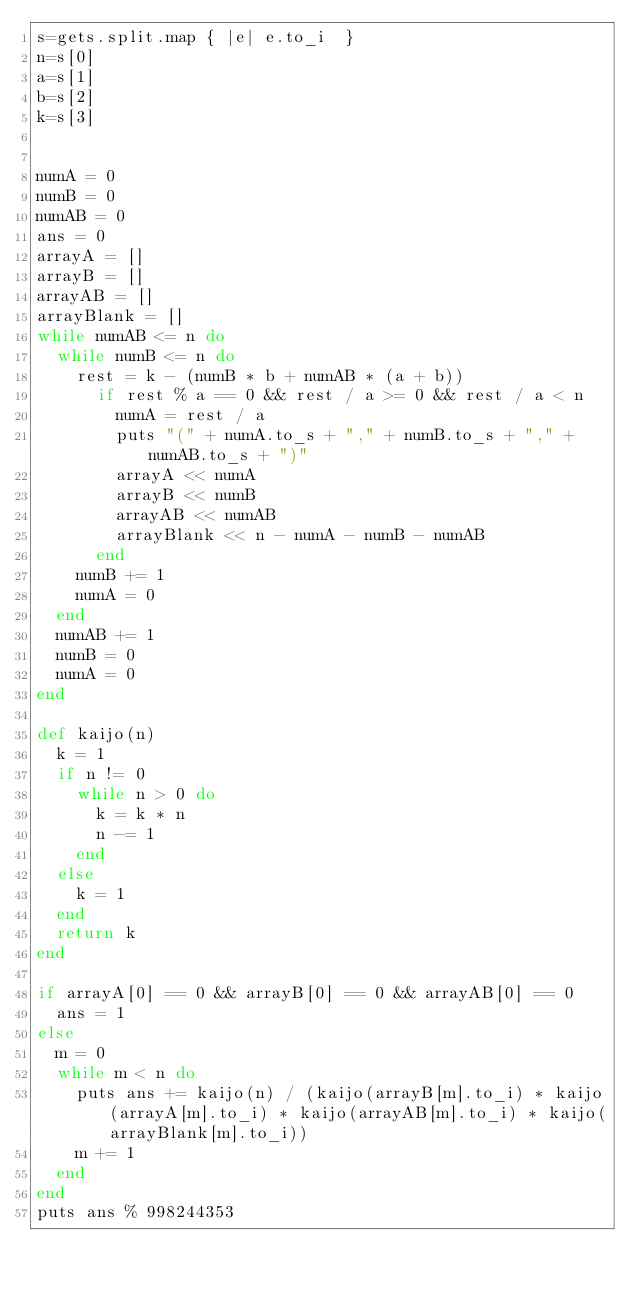Convert code to text. <code><loc_0><loc_0><loc_500><loc_500><_Ruby_>s=gets.split.map { |e| e.to_i  }
n=s[0]
a=s[1]
b=s[2]
k=s[3]


numA = 0
numB = 0
numAB = 0
ans = 0
arrayA = []
arrayB = []
arrayAB = []
arrayBlank = []
while numAB <= n do
  while numB <= n do
    rest = k - (numB * b + numAB * (a + b))
      if rest % a == 0 && rest / a >= 0 && rest / a < n
        numA = rest / a
        puts "(" + numA.to_s + "," + numB.to_s + "," + numAB.to_s + ")"
        arrayA << numA
        arrayB << numB
        arrayAB << numAB
        arrayBlank << n - numA - numB - numAB
      end
    numB += 1
    numA = 0
  end
  numAB += 1
  numB = 0
  numA = 0
end

def kaijo(n)
  k = 1
  if n != 0
    while n > 0 do
      k = k * n
      n -= 1
    end
  else
    k = 1
  end
  return k
end

if arrayA[0] == 0 && arrayB[0] == 0 && arrayAB[0] == 0
  ans = 1
else
  m = 0
  while m < n do
    puts ans += kaijo(n) / (kaijo(arrayB[m].to_i) * kaijo(arrayA[m].to_i) * kaijo(arrayAB[m].to_i) * kaijo(arrayBlank[m].to_i))
    m += 1
  end
end
puts ans % 998244353
</code> 